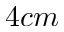Convert formula to latex. <formula><loc_0><loc_0><loc_500><loc_500>4 c m</formula> 